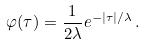<formula> <loc_0><loc_0><loc_500><loc_500>\varphi ( \tau ) = \frac { 1 } { 2 \lambda } e ^ { - | \tau | / \lambda } \, .</formula> 